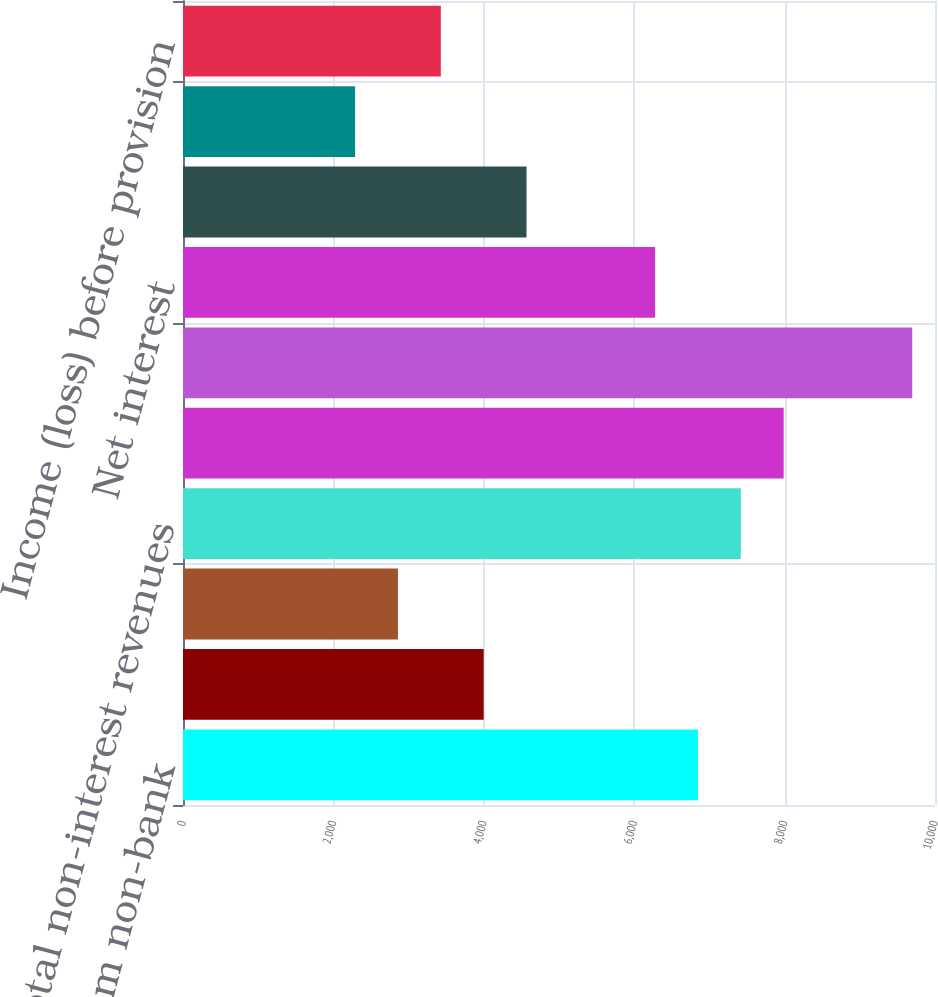<chart> <loc_0><loc_0><loc_500><loc_500><bar_chart><fcel>Dividends from non-bank<fcel>Principal transactions<fcel>Other<fcel>Total non-interest revenues<fcel>Interest income<fcel>Interest expense<fcel>Net interest<fcel>Net revenues<fcel>Non-interest expenses<fcel>Income (loss) before provision<nl><fcel>6847.8<fcel>3998.3<fcel>2858.5<fcel>7417.7<fcel>7987.6<fcel>9697.3<fcel>6277.9<fcel>4568.2<fcel>2288.6<fcel>3428.4<nl></chart> 